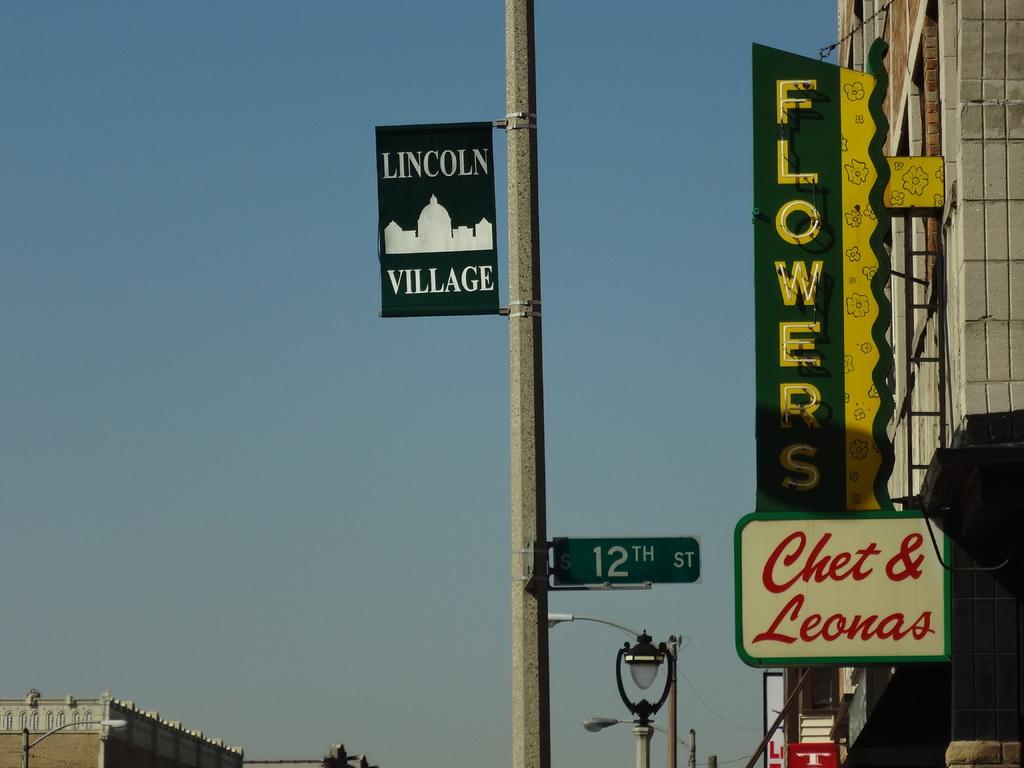What street is the sign on?
Your answer should be compact. 12th. What is the name of the village?
Ensure brevity in your answer.  Lincoln village. 